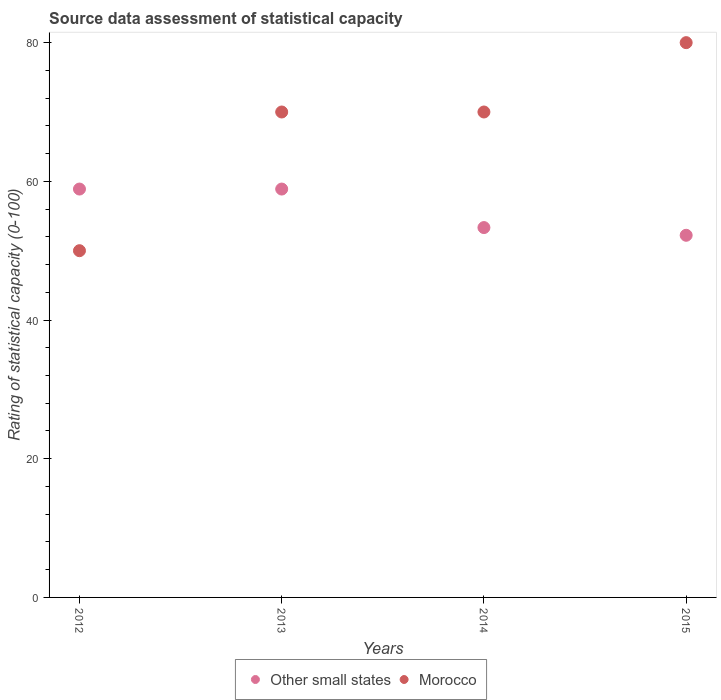What is the rating of statistical capacity in Other small states in 2012?
Offer a very short reply. 58.89. Across all years, what is the maximum rating of statistical capacity in Morocco?
Ensure brevity in your answer.  80. Across all years, what is the minimum rating of statistical capacity in Morocco?
Provide a succinct answer. 50. In which year was the rating of statistical capacity in Morocco minimum?
Your response must be concise. 2012. What is the total rating of statistical capacity in Morocco in the graph?
Make the answer very short. 270. What is the difference between the rating of statistical capacity in Other small states in 2014 and that in 2015?
Give a very brief answer. 1.11. What is the difference between the rating of statistical capacity in Morocco in 2015 and the rating of statistical capacity in Other small states in 2014?
Your response must be concise. 26.67. What is the average rating of statistical capacity in Other small states per year?
Your answer should be very brief. 55.83. In the year 2015, what is the difference between the rating of statistical capacity in Morocco and rating of statistical capacity in Other small states?
Provide a short and direct response. 27.78. In how many years, is the rating of statistical capacity in Morocco greater than 56?
Give a very brief answer. 3. What is the ratio of the rating of statistical capacity in Morocco in 2013 to that in 2015?
Offer a terse response. 0.88. Is the difference between the rating of statistical capacity in Morocco in 2012 and 2014 greater than the difference between the rating of statistical capacity in Other small states in 2012 and 2014?
Make the answer very short. No. What is the difference between the highest and the second highest rating of statistical capacity in Morocco?
Give a very brief answer. 10. What is the difference between the highest and the lowest rating of statistical capacity in Other small states?
Your answer should be compact. 6.67. In how many years, is the rating of statistical capacity in Other small states greater than the average rating of statistical capacity in Other small states taken over all years?
Provide a succinct answer. 2. Is the sum of the rating of statistical capacity in Other small states in 2014 and 2015 greater than the maximum rating of statistical capacity in Morocco across all years?
Provide a succinct answer. Yes. Does the rating of statistical capacity in Morocco monotonically increase over the years?
Provide a succinct answer. No. Is the rating of statistical capacity in Morocco strictly greater than the rating of statistical capacity in Other small states over the years?
Offer a terse response. No. Is the rating of statistical capacity in Other small states strictly less than the rating of statistical capacity in Morocco over the years?
Offer a terse response. No. How many dotlines are there?
Give a very brief answer. 2. How many years are there in the graph?
Ensure brevity in your answer.  4. Are the values on the major ticks of Y-axis written in scientific E-notation?
Your answer should be compact. No. Does the graph contain any zero values?
Keep it short and to the point. No. Where does the legend appear in the graph?
Provide a succinct answer. Bottom center. What is the title of the graph?
Offer a terse response. Source data assessment of statistical capacity. What is the label or title of the X-axis?
Your response must be concise. Years. What is the label or title of the Y-axis?
Ensure brevity in your answer.  Rating of statistical capacity (0-100). What is the Rating of statistical capacity (0-100) in Other small states in 2012?
Your answer should be very brief. 58.89. What is the Rating of statistical capacity (0-100) in Morocco in 2012?
Keep it short and to the point. 50. What is the Rating of statistical capacity (0-100) in Other small states in 2013?
Give a very brief answer. 58.89. What is the Rating of statistical capacity (0-100) in Morocco in 2013?
Give a very brief answer. 70. What is the Rating of statistical capacity (0-100) of Other small states in 2014?
Provide a succinct answer. 53.33. What is the Rating of statistical capacity (0-100) in Morocco in 2014?
Ensure brevity in your answer.  70. What is the Rating of statistical capacity (0-100) of Other small states in 2015?
Your answer should be compact. 52.22. Across all years, what is the maximum Rating of statistical capacity (0-100) of Other small states?
Give a very brief answer. 58.89. Across all years, what is the maximum Rating of statistical capacity (0-100) of Morocco?
Your answer should be compact. 80. Across all years, what is the minimum Rating of statistical capacity (0-100) in Other small states?
Your response must be concise. 52.22. Across all years, what is the minimum Rating of statistical capacity (0-100) of Morocco?
Make the answer very short. 50. What is the total Rating of statistical capacity (0-100) in Other small states in the graph?
Make the answer very short. 223.33. What is the total Rating of statistical capacity (0-100) in Morocco in the graph?
Keep it short and to the point. 270. What is the difference between the Rating of statistical capacity (0-100) in Other small states in 2012 and that in 2013?
Make the answer very short. 0. What is the difference between the Rating of statistical capacity (0-100) of Morocco in 2012 and that in 2013?
Offer a terse response. -20. What is the difference between the Rating of statistical capacity (0-100) of Other small states in 2012 and that in 2014?
Provide a short and direct response. 5.56. What is the difference between the Rating of statistical capacity (0-100) of Other small states in 2012 and that in 2015?
Keep it short and to the point. 6.67. What is the difference between the Rating of statistical capacity (0-100) in Morocco in 2012 and that in 2015?
Give a very brief answer. -30. What is the difference between the Rating of statistical capacity (0-100) of Other small states in 2013 and that in 2014?
Your response must be concise. 5.56. What is the difference between the Rating of statistical capacity (0-100) in Morocco in 2013 and that in 2015?
Offer a very short reply. -10. What is the difference between the Rating of statistical capacity (0-100) of Other small states in 2012 and the Rating of statistical capacity (0-100) of Morocco in 2013?
Your answer should be very brief. -11.11. What is the difference between the Rating of statistical capacity (0-100) in Other small states in 2012 and the Rating of statistical capacity (0-100) in Morocco in 2014?
Provide a succinct answer. -11.11. What is the difference between the Rating of statistical capacity (0-100) of Other small states in 2012 and the Rating of statistical capacity (0-100) of Morocco in 2015?
Offer a terse response. -21.11. What is the difference between the Rating of statistical capacity (0-100) in Other small states in 2013 and the Rating of statistical capacity (0-100) in Morocco in 2014?
Provide a short and direct response. -11.11. What is the difference between the Rating of statistical capacity (0-100) of Other small states in 2013 and the Rating of statistical capacity (0-100) of Morocco in 2015?
Offer a terse response. -21.11. What is the difference between the Rating of statistical capacity (0-100) of Other small states in 2014 and the Rating of statistical capacity (0-100) of Morocco in 2015?
Ensure brevity in your answer.  -26.67. What is the average Rating of statistical capacity (0-100) in Other small states per year?
Provide a succinct answer. 55.83. What is the average Rating of statistical capacity (0-100) in Morocco per year?
Your answer should be very brief. 67.5. In the year 2012, what is the difference between the Rating of statistical capacity (0-100) of Other small states and Rating of statistical capacity (0-100) of Morocco?
Your answer should be compact. 8.89. In the year 2013, what is the difference between the Rating of statistical capacity (0-100) in Other small states and Rating of statistical capacity (0-100) in Morocco?
Give a very brief answer. -11.11. In the year 2014, what is the difference between the Rating of statistical capacity (0-100) of Other small states and Rating of statistical capacity (0-100) of Morocco?
Keep it short and to the point. -16.67. In the year 2015, what is the difference between the Rating of statistical capacity (0-100) in Other small states and Rating of statistical capacity (0-100) in Morocco?
Your answer should be very brief. -27.78. What is the ratio of the Rating of statistical capacity (0-100) in Other small states in 2012 to that in 2013?
Offer a very short reply. 1. What is the ratio of the Rating of statistical capacity (0-100) of Morocco in 2012 to that in 2013?
Ensure brevity in your answer.  0.71. What is the ratio of the Rating of statistical capacity (0-100) in Other small states in 2012 to that in 2014?
Your response must be concise. 1.1. What is the ratio of the Rating of statistical capacity (0-100) of Morocco in 2012 to that in 2014?
Your answer should be very brief. 0.71. What is the ratio of the Rating of statistical capacity (0-100) in Other small states in 2012 to that in 2015?
Offer a very short reply. 1.13. What is the ratio of the Rating of statistical capacity (0-100) in Morocco in 2012 to that in 2015?
Make the answer very short. 0.62. What is the ratio of the Rating of statistical capacity (0-100) of Other small states in 2013 to that in 2014?
Provide a short and direct response. 1.1. What is the ratio of the Rating of statistical capacity (0-100) of Other small states in 2013 to that in 2015?
Your answer should be compact. 1.13. What is the ratio of the Rating of statistical capacity (0-100) in Other small states in 2014 to that in 2015?
Give a very brief answer. 1.02. What is the difference between the highest and the lowest Rating of statistical capacity (0-100) in Morocco?
Provide a succinct answer. 30. 